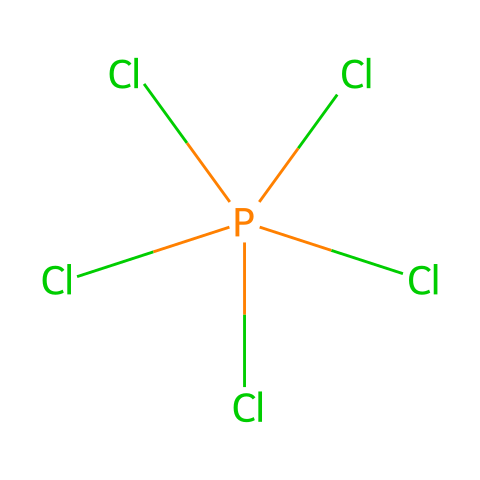What is the name of this chemical? The chemical is named phosphorus pentachloride, which is indicated by the presence of a phosphorus atom bonded to five chlorine atoms.
Answer: phosphorus pentachloride How many chlorine atoms are present in the structure? The structure clearly shows five chlorine atoms bonded to a single phosphorus atom, as identified by the symbols and their connections.
Answer: 5 What type of chemical bonding is present in phosphorus pentachloride? The bonding between the phosphorus and chlorine atoms is covalent, as indicated by the shared electrons characteristic of non-metal interactions.
Answer: covalent Is phosphorus pentachloride a hypervalent compound? Yes, phosphorus pentachloride is considered a hypervalent compound because the phosphorus atom exceeds the octet rule by accommodating more than four bonds (five in this case).
Answer: yes What is the oxidation state of phosphorus in phosphorus pentachloride? The oxidation state of phosphorus in this compound can be determined by assuming that each chlorine atom has an oxidation state of -1. Thus, phosphorus would be +5 to balance the five -1 charges.
Answer: +5 What is a common application of phosphorus pentachloride? Phosphorus pentachloride is commonly used in the manufacture of semiconductors, where it serves as a chlorinating agent.
Answer: semiconductor manufacturing 